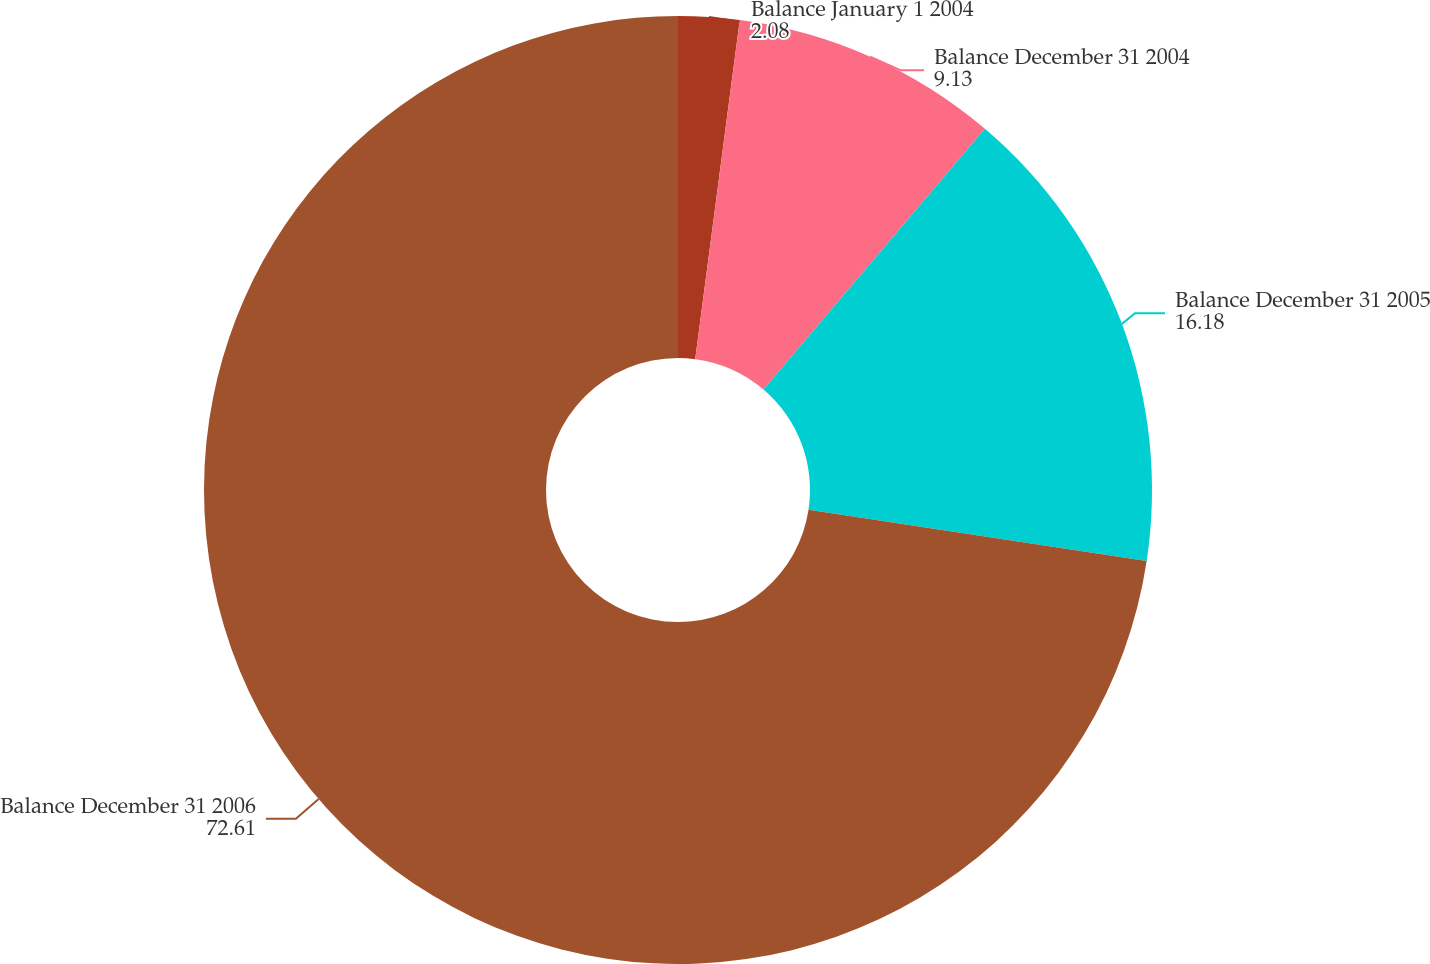Convert chart to OTSL. <chart><loc_0><loc_0><loc_500><loc_500><pie_chart><fcel>Balance January 1 2004<fcel>Balance December 31 2004<fcel>Balance December 31 2005<fcel>Balance December 31 2006<nl><fcel>2.08%<fcel>9.13%<fcel>16.18%<fcel>72.61%<nl></chart> 